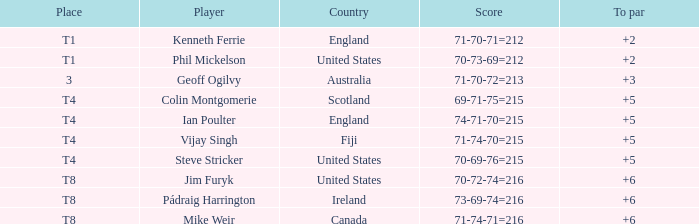What athlete held the spot of t1 in to par and recorded a score of 70-73-69=212? 2.0. 